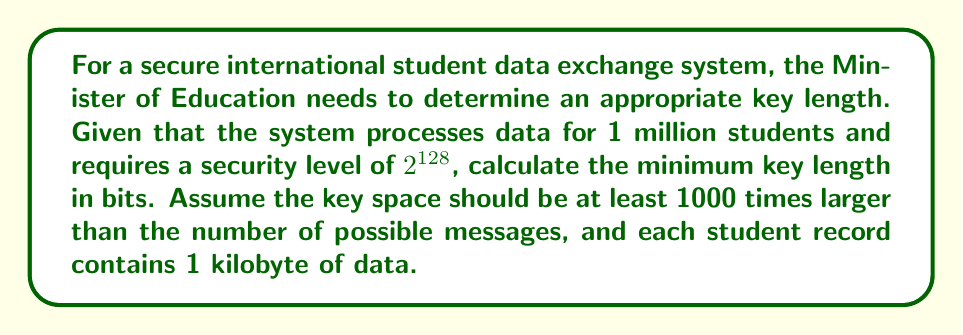Teach me how to tackle this problem. 1. Calculate the total data size:
   $1,000,000 \text{ students} \times 1 \text{ kilobyte} = 1,000,000 \text{ kilobytes} = 8,000,000,000 \text{ bits}$

2. Determine the number of possible messages:
   $2^{8,000,000,000}$ (since each bit can be 0 or 1)

3. Calculate the required key space size:
   $\text{Key space} \geq 1000 \times 2^{8,000,000,000}$

4. Express the key space in terms of bits:
   $2^{\text{key length}} \geq 1000 \times 2^{8,000,000,000}$

5. Take the logarithm of both sides:
   $\text{key length} \geq \log_2(1000) + 8,000,000,000$

6. Simplify:
   $\text{key length} \geq 9.97 + 8,000,000,000 \approx 8,000,000,010$ bits

7. Compare with the required security level:
   $8,000,000,010 \text{ bits} > 128 \text{ bits}$

8. Choose the larger value as the minimum key length:
   $\text{Minimum key length} = 8,000,000,010 \text{ bits}$
Answer: 8,000,000,010 bits 